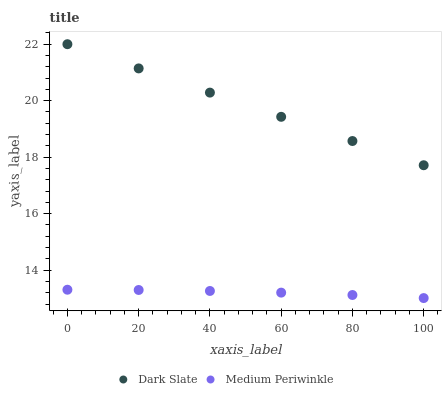Does Medium Periwinkle have the minimum area under the curve?
Answer yes or no. Yes. Does Dark Slate have the maximum area under the curve?
Answer yes or no. Yes. Does Medium Periwinkle have the maximum area under the curve?
Answer yes or no. No. Is Dark Slate the smoothest?
Answer yes or no. Yes. Is Medium Periwinkle the roughest?
Answer yes or no. Yes. Is Medium Periwinkle the smoothest?
Answer yes or no. No. Does Medium Periwinkle have the lowest value?
Answer yes or no. Yes. Does Dark Slate have the highest value?
Answer yes or no. Yes. Does Medium Periwinkle have the highest value?
Answer yes or no. No. Is Medium Periwinkle less than Dark Slate?
Answer yes or no. Yes. Is Dark Slate greater than Medium Periwinkle?
Answer yes or no. Yes. Does Medium Periwinkle intersect Dark Slate?
Answer yes or no. No. 